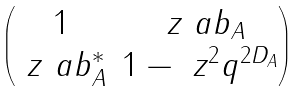<formula> <loc_0><loc_0><loc_500><loc_500>\begin{pmatrix} 1 & \ z \ a b _ { A } \\ \ z \ a b ^ { * } _ { A } & 1 - \ z ^ { 2 } q ^ { 2 D _ { A } } \end{pmatrix}</formula> 